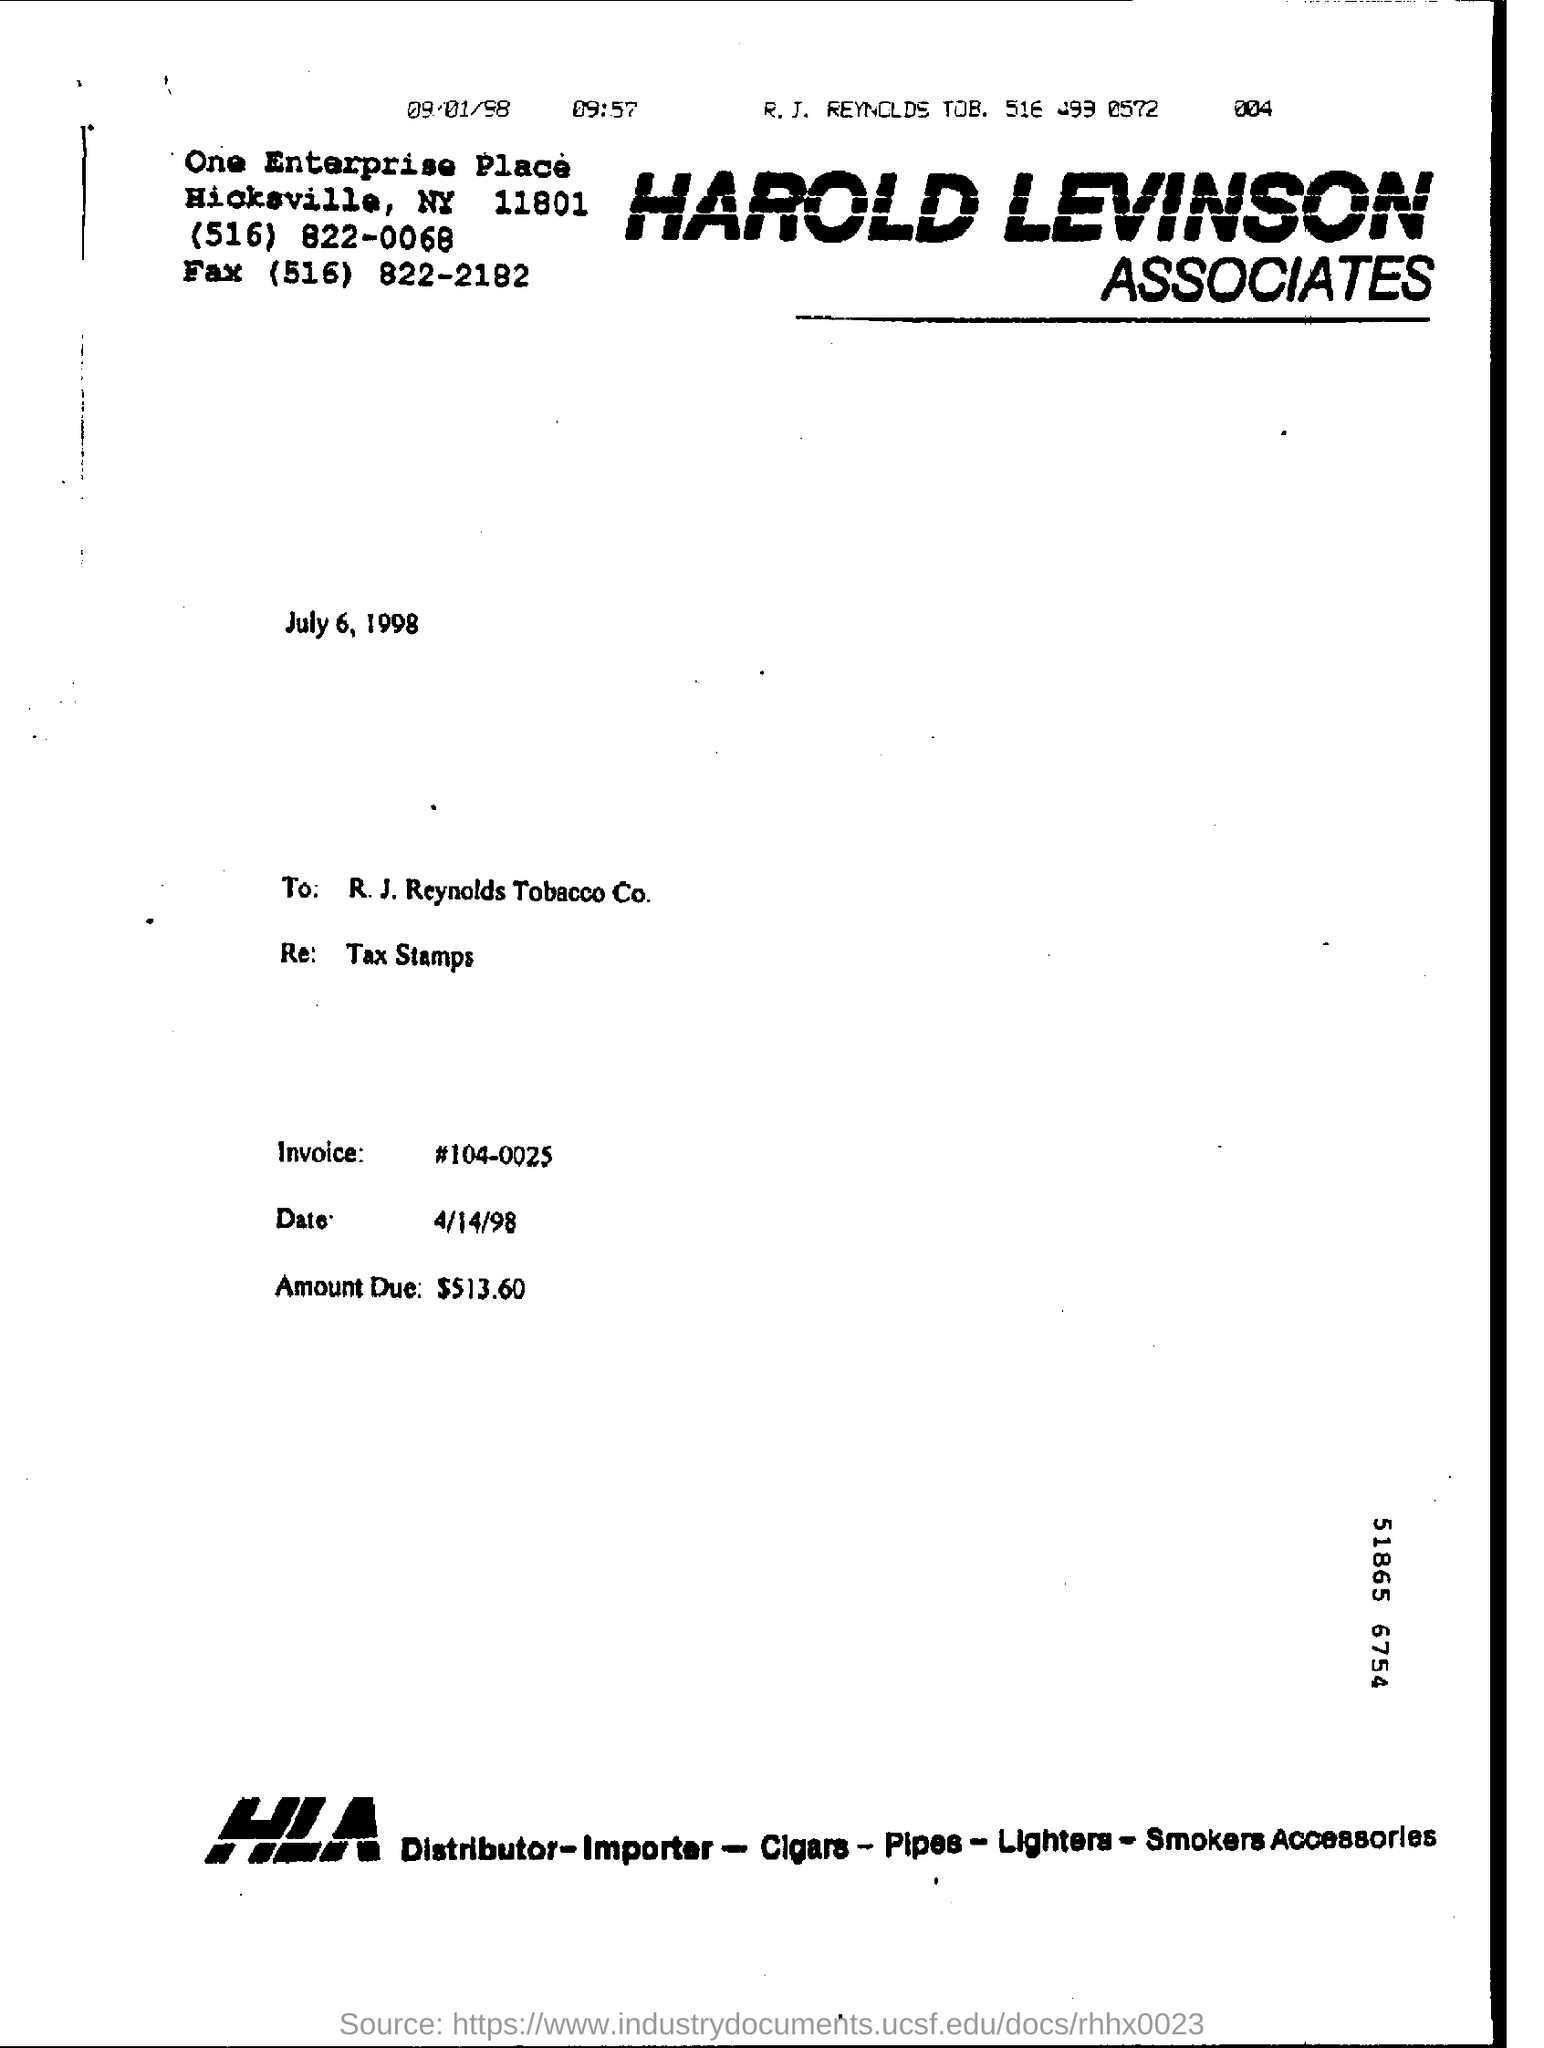Draw attention to some important aspects in this diagram. The amount due to be paid is $513.60. The invoice date is April 14th, 1998. The headline of this document is 'Harold Levinson Associates.' The amount due is $513.60. The invoice number is 104-0025. 